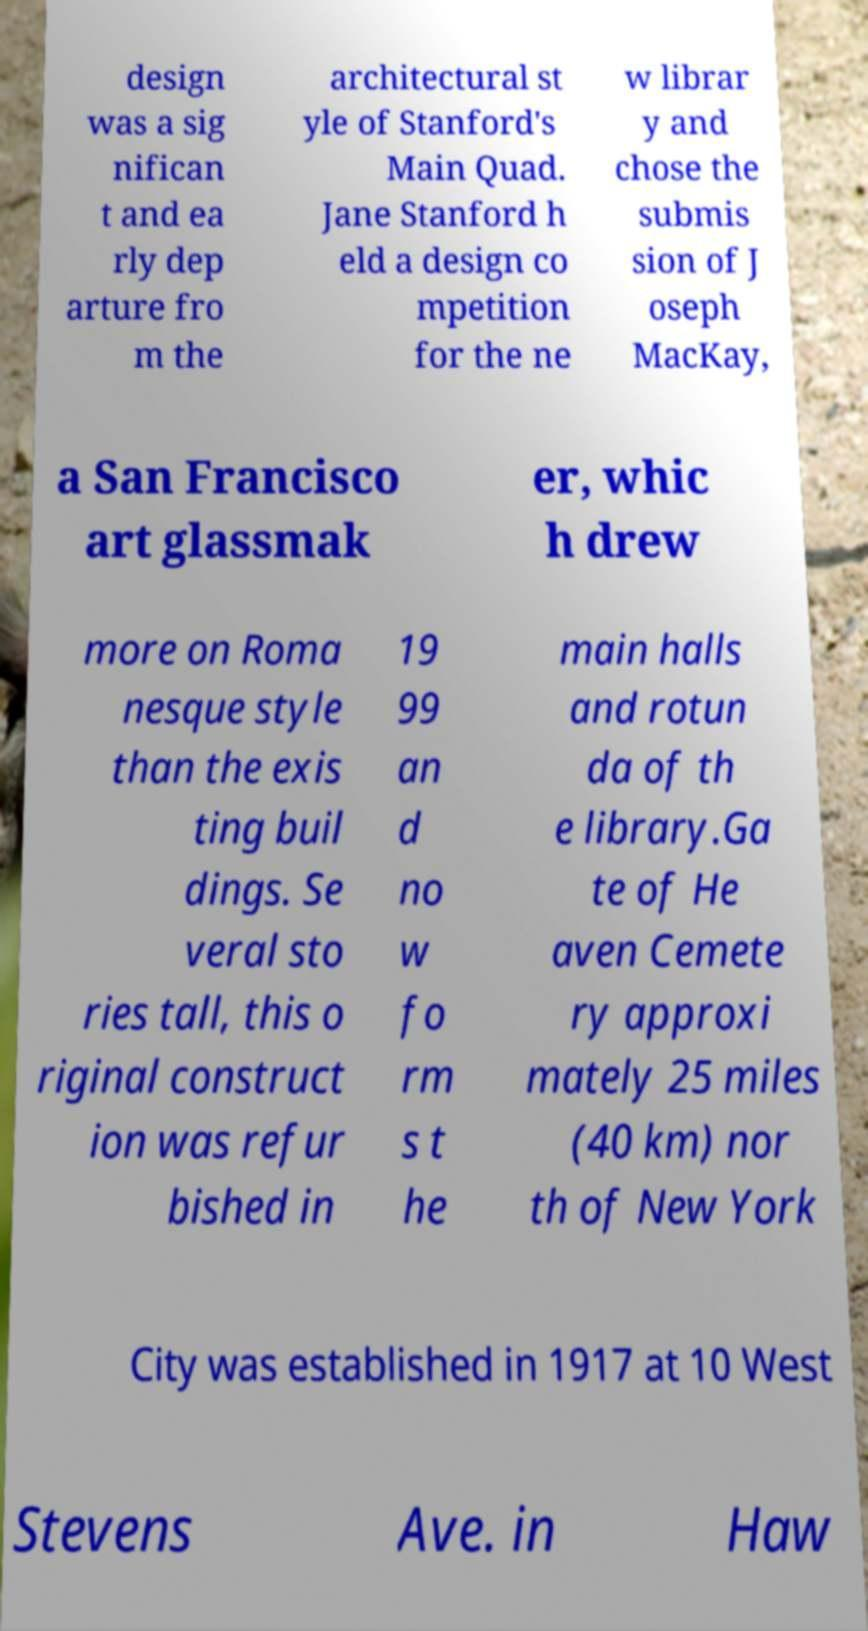Please read and relay the text visible in this image. What does it say? design was a sig nifican t and ea rly dep arture fro m the architectural st yle of Stanford's Main Quad. Jane Stanford h eld a design co mpetition for the ne w librar y and chose the submis sion of J oseph MacKay, a San Francisco art glassmak er, whic h drew more on Roma nesque style than the exis ting buil dings. Se veral sto ries tall, this o riginal construct ion was refur bished in 19 99 an d no w fo rm s t he main halls and rotun da of th e library.Ga te of He aven Cemete ry approxi mately 25 miles (40 km) nor th of New York City was established in 1917 at 10 West Stevens Ave. in Haw 